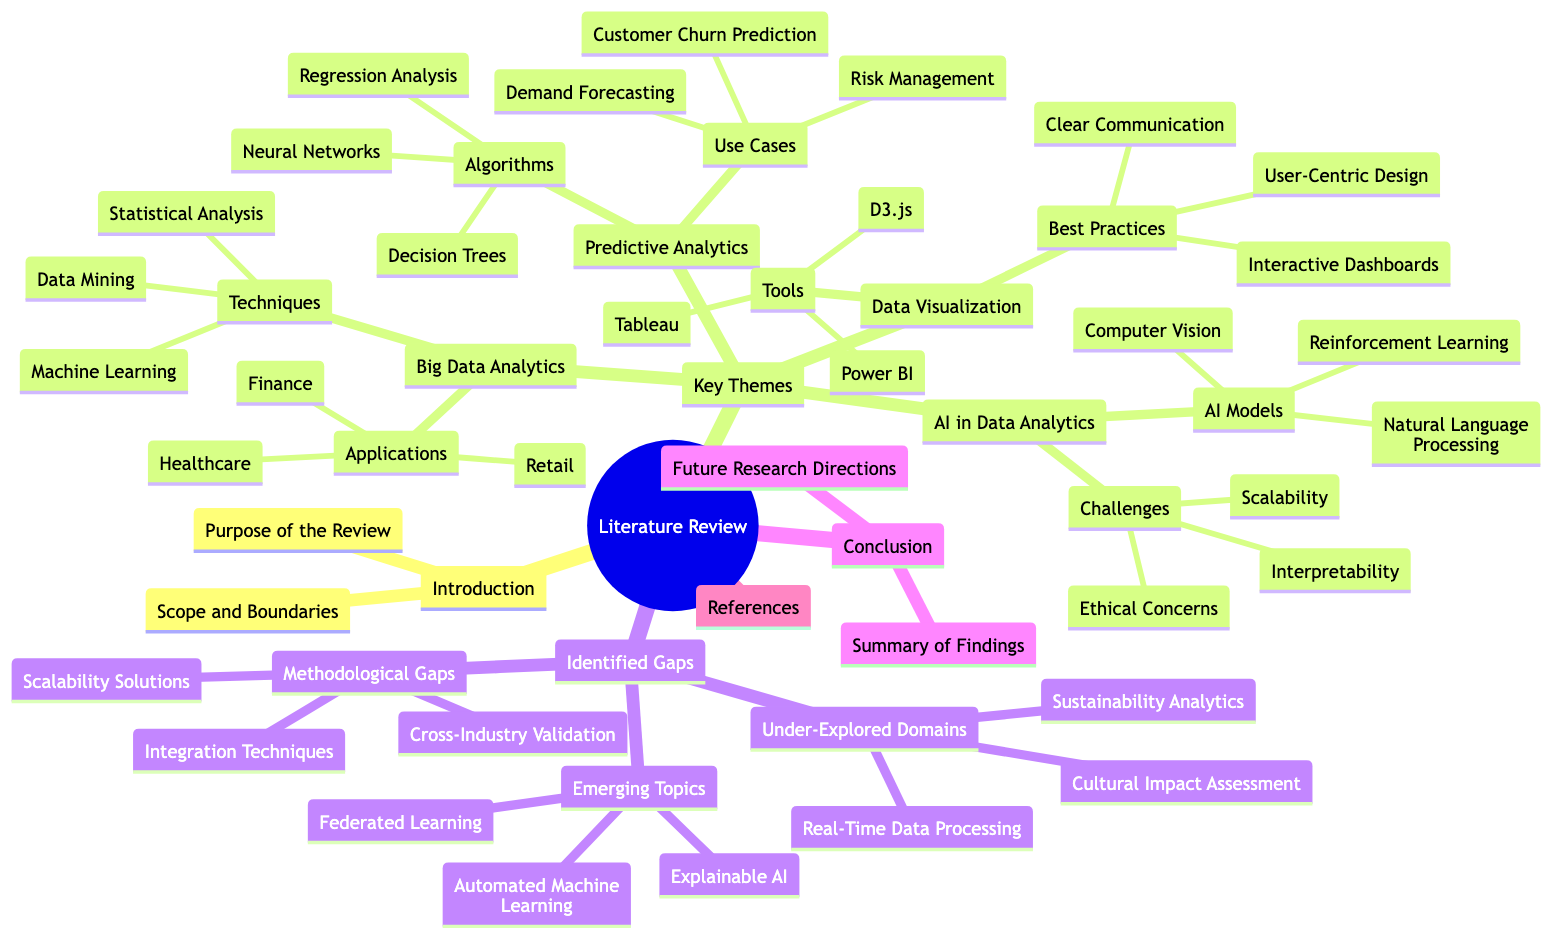What are the techniques under Big Data Analytics? The node "Techniques" is a child of "Big Data Analytics," which lists three specific techniques: Machine Learning, Statistical Analysis, and Data Mining.
Answer: Machine Learning, Statistical Analysis, Data Mining How many AI Models are listed in the literature review? Under the main theme "AI in Data Analytics," there is a node named "AI Models" that includes three items: Natural Language Processing, Computer Vision, and Reinforcement Learning. Therefore, the count of AI Models is three.
Answer: 3 What is one application of Big Data Analytics? The category "Applications" under "Big Data Analytics" includes three examples: Healthcare, Retail, and Finance. Any one of these answers the question, but the simplest is to name just one.
Answer: Healthcare What are the emerging topics identified in the literature review? The section "Emerging Topics" under "Identified Gaps" lists three specific areas: Explainable AI, Federated Learning, and Automated Machine Learning. To answer the question, any one of these emerging topics can be provided.
Answer: Explainable AI What is a challenge mentioned in AI in Data Analytics? In the "Challenges" node under "AI in Data Analytics," there are three challenges listed: Ethical Concerns, Interpretability, and Scalability. Naming any of these challenges would provide the answer.
Answer: Ethical Concerns What is the primary focus of the "Conclusion" section? The "Conclusion" section comprises two nodes: "Summary of Findings" and "Future Research Directions." Thus, the answer is to indicate that the section contains these two focus areas.
Answer: Summary of Findings, Future Research Directions How many under-explored domains are listed in the identified gaps? Under "Under-Explored Domains" in the "Identified Gaps" section, there are three items: Sustainability Analytics, Cultural Impact Assessment, and Real-Time Data Processing. Therefore, the total number is three.
Answer: 3 Which tool is mentioned for Data Visualization? The "Tools" list under "Data Visualization" includes three tools: Tableau, Power BI, and D3.js. Any of these tools would suffice to answer the question appropriately.
Answer: Tableau What relationships can be observed between Key Themes and Identified Gaps? The diagram indicates that "Key Themes" and "Identified Gaps" are both primary branches stemming from the "Literature Review" root. The relationship is that the identified gaps are areas lacking adequate research related to the key themes outlined.
Answer: Relationships in focus on research areas 